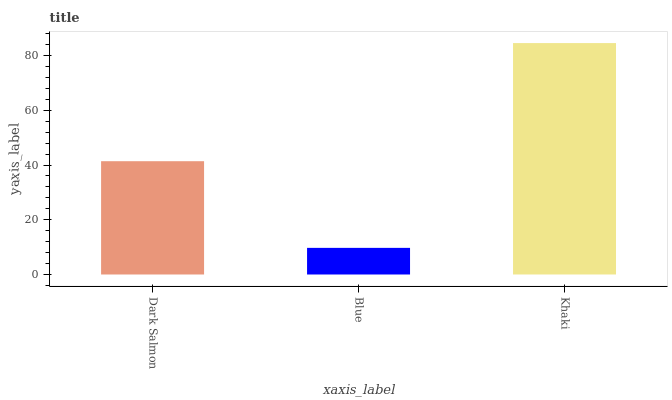Is Blue the minimum?
Answer yes or no. Yes. Is Khaki the maximum?
Answer yes or no. Yes. Is Khaki the minimum?
Answer yes or no. No. Is Blue the maximum?
Answer yes or no. No. Is Khaki greater than Blue?
Answer yes or no. Yes. Is Blue less than Khaki?
Answer yes or no. Yes. Is Blue greater than Khaki?
Answer yes or no. No. Is Khaki less than Blue?
Answer yes or no. No. Is Dark Salmon the high median?
Answer yes or no. Yes. Is Dark Salmon the low median?
Answer yes or no. Yes. Is Blue the high median?
Answer yes or no. No. Is Blue the low median?
Answer yes or no. No. 